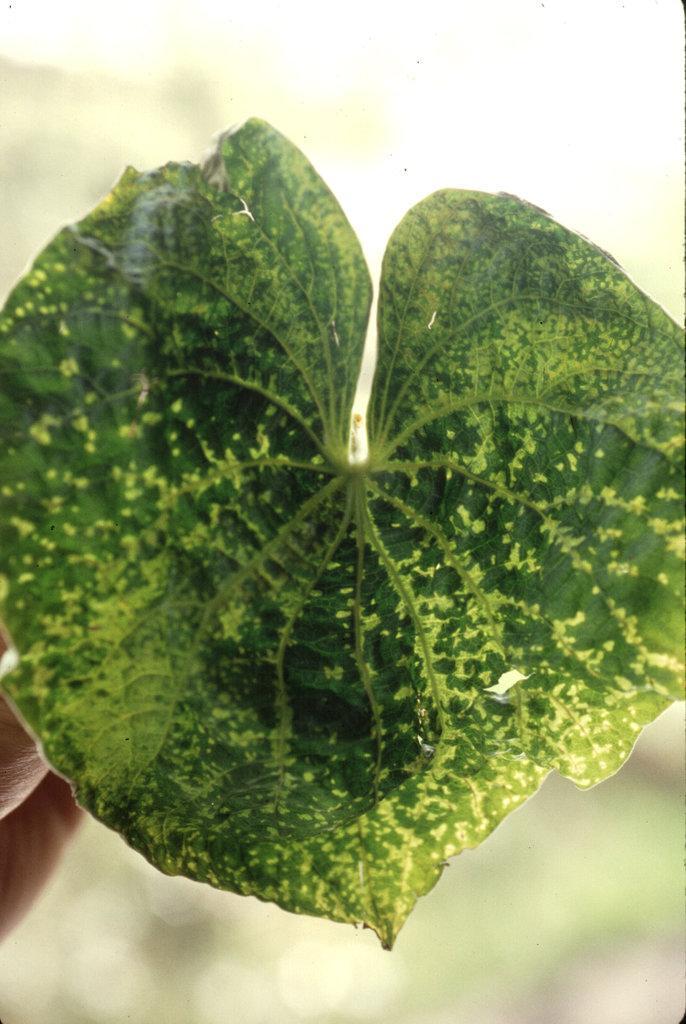Please provide a concise description of this image. This is the zoom-in picture of a leaf which is in green color. 